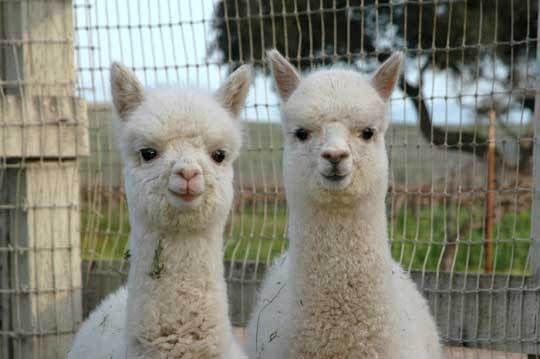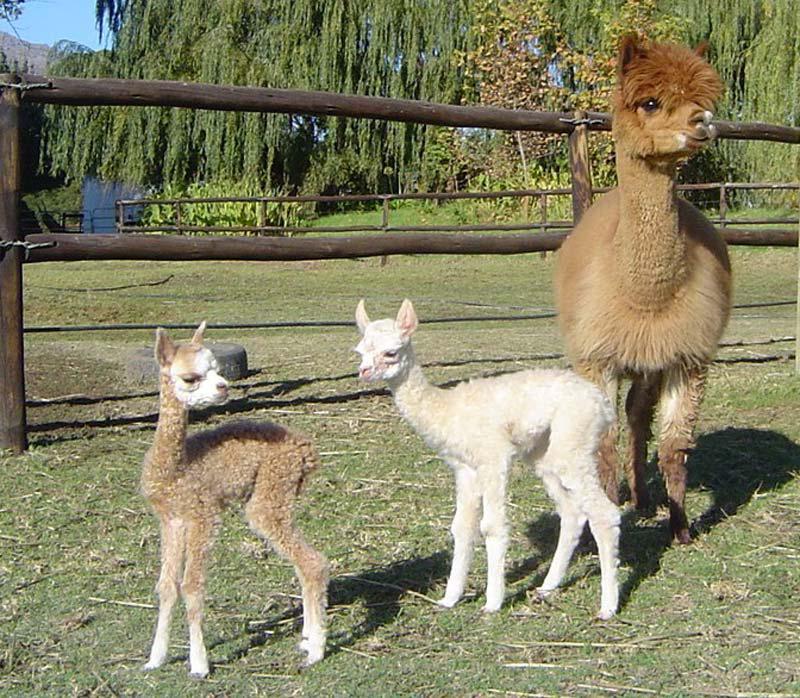The first image is the image on the left, the second image is the image on the right. For the images shown, is this caption "One of the images show only two llamas that are facing the same direction as the other." true? Answer yes or no. Yes. The first image is the image on the left, the second image is the image on the right. Evaluate the accuracy of this statement regarding the images: "In the right image, a baby llama with its body turned left and its head turned right is standing near a standing adult llama.". Is it true? Answer yes or no. Yes. 